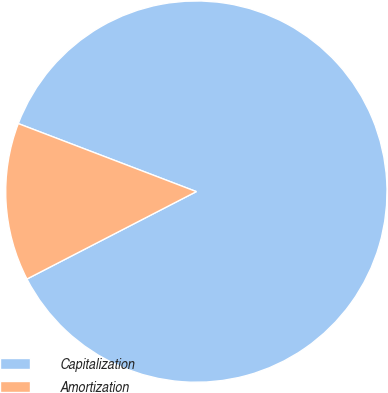<chart> <loc_0><loc_0><loc_500><loc_500><pie_chart><fcel>Capitalization<fcel>Amortization<nl><fcel>86.61%<fcel>13.39%<nl></chart> 